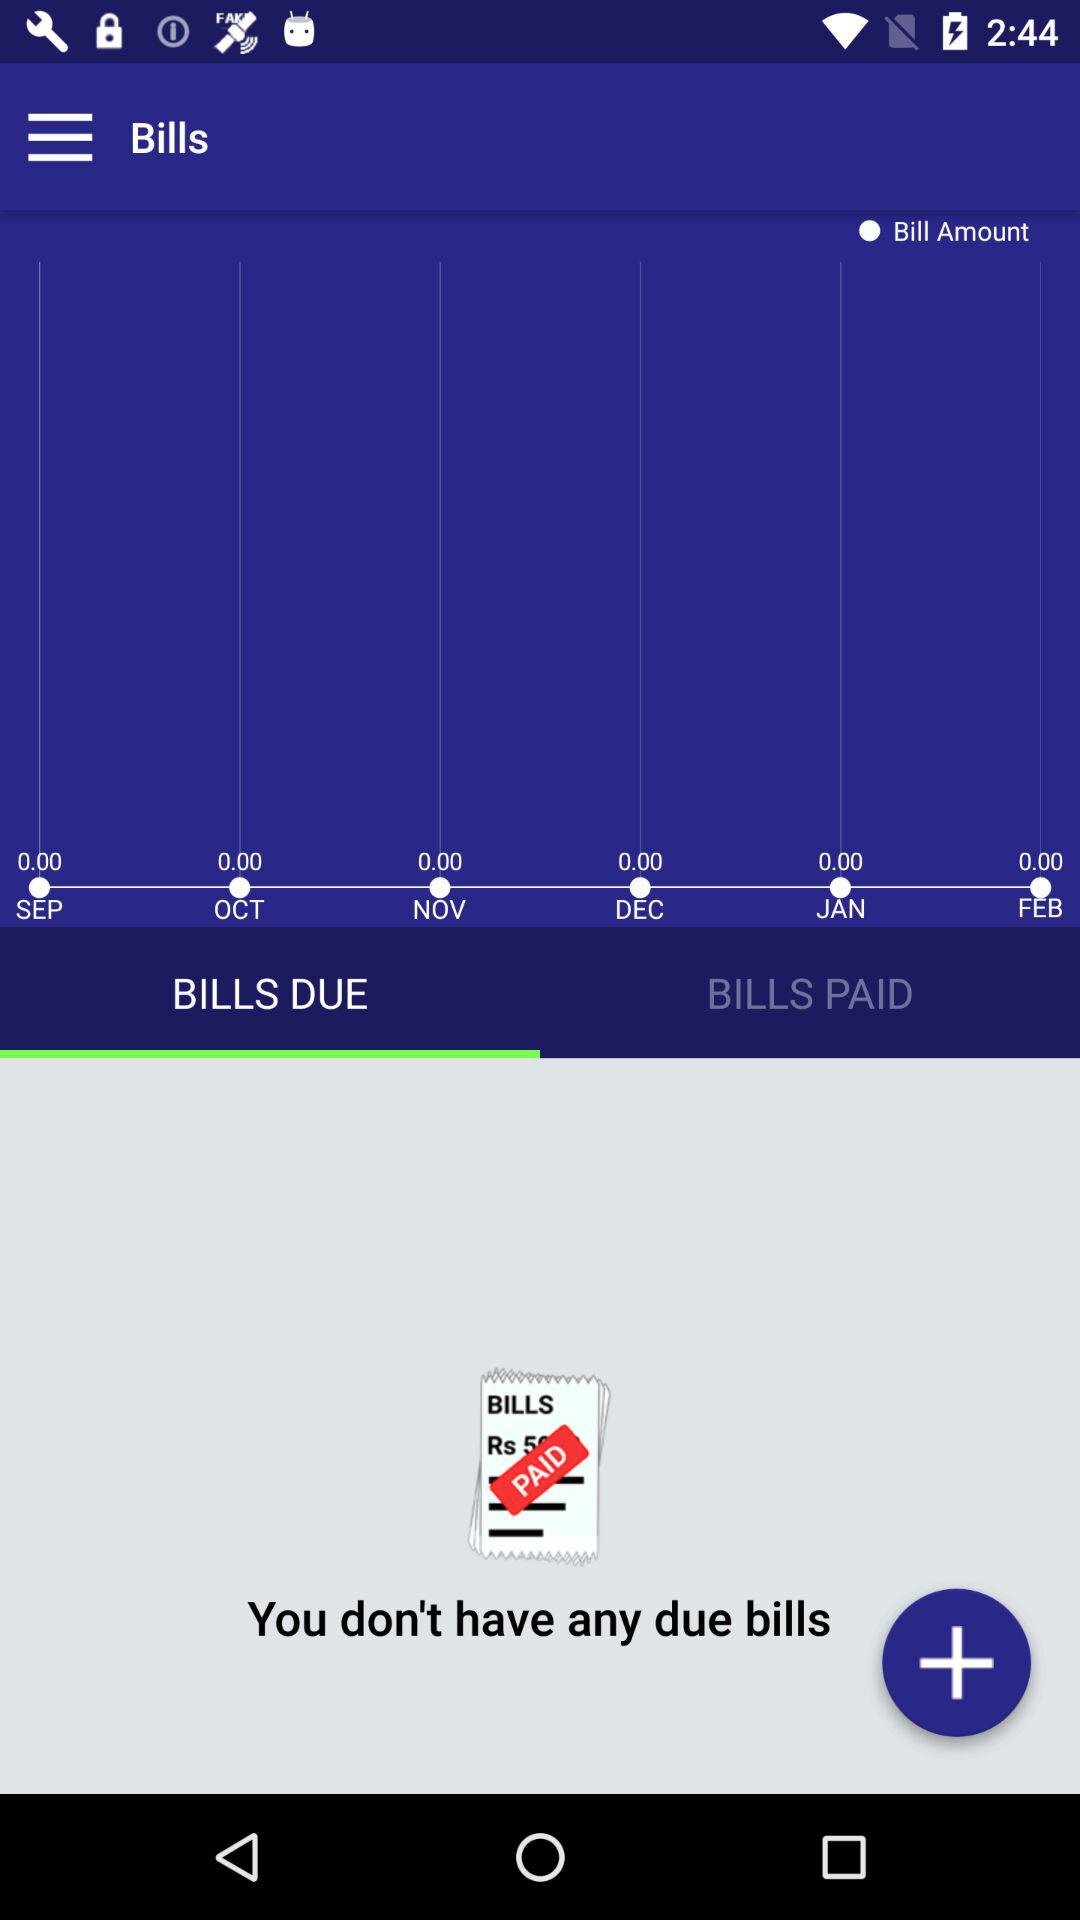How many bills are unpaid?
Answer the question using a single word or phrase. 0 